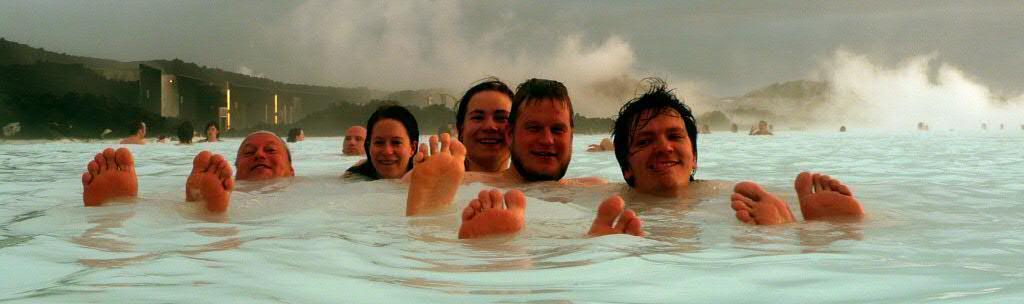Please provide a concise description of this image. In this picture we can see there are groups of people in the water. Behind the people, it looks like a building and there are hills, fog and the sky. 